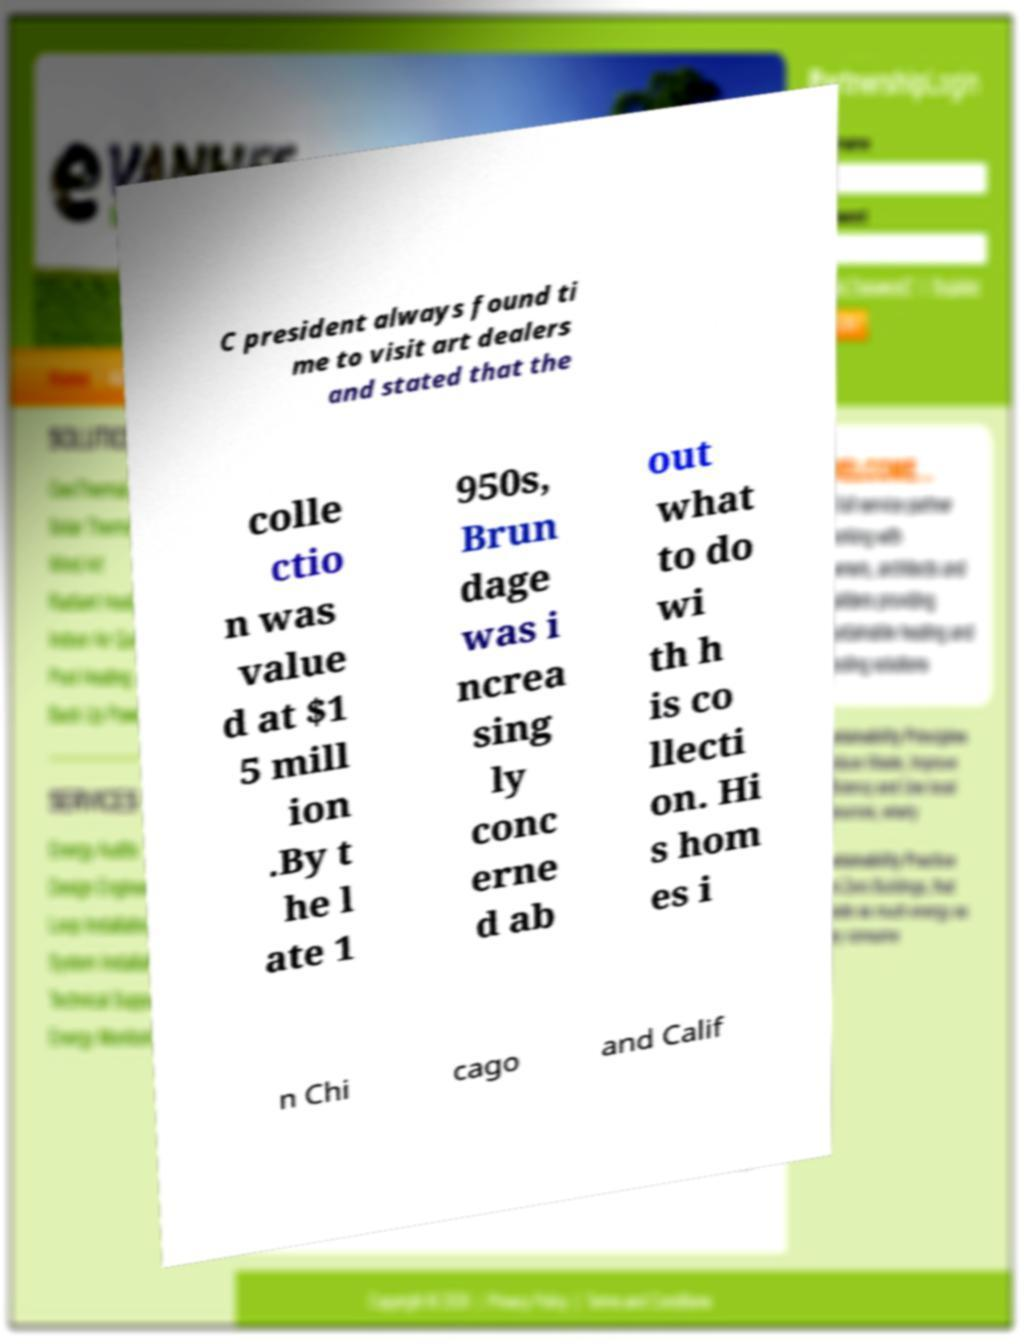I need the written content from this picture converted into text. Can you do that? C president always found ti me to visit art dealers and stated that the colle ctio n was value d at $1 5 mill ion .By t he l ate 1 950s, Brun dage was i ncrea sing ly conc erne d ab out what to do wi th h is co llecti on. Hi s hom es i n Chi cago and Calif 